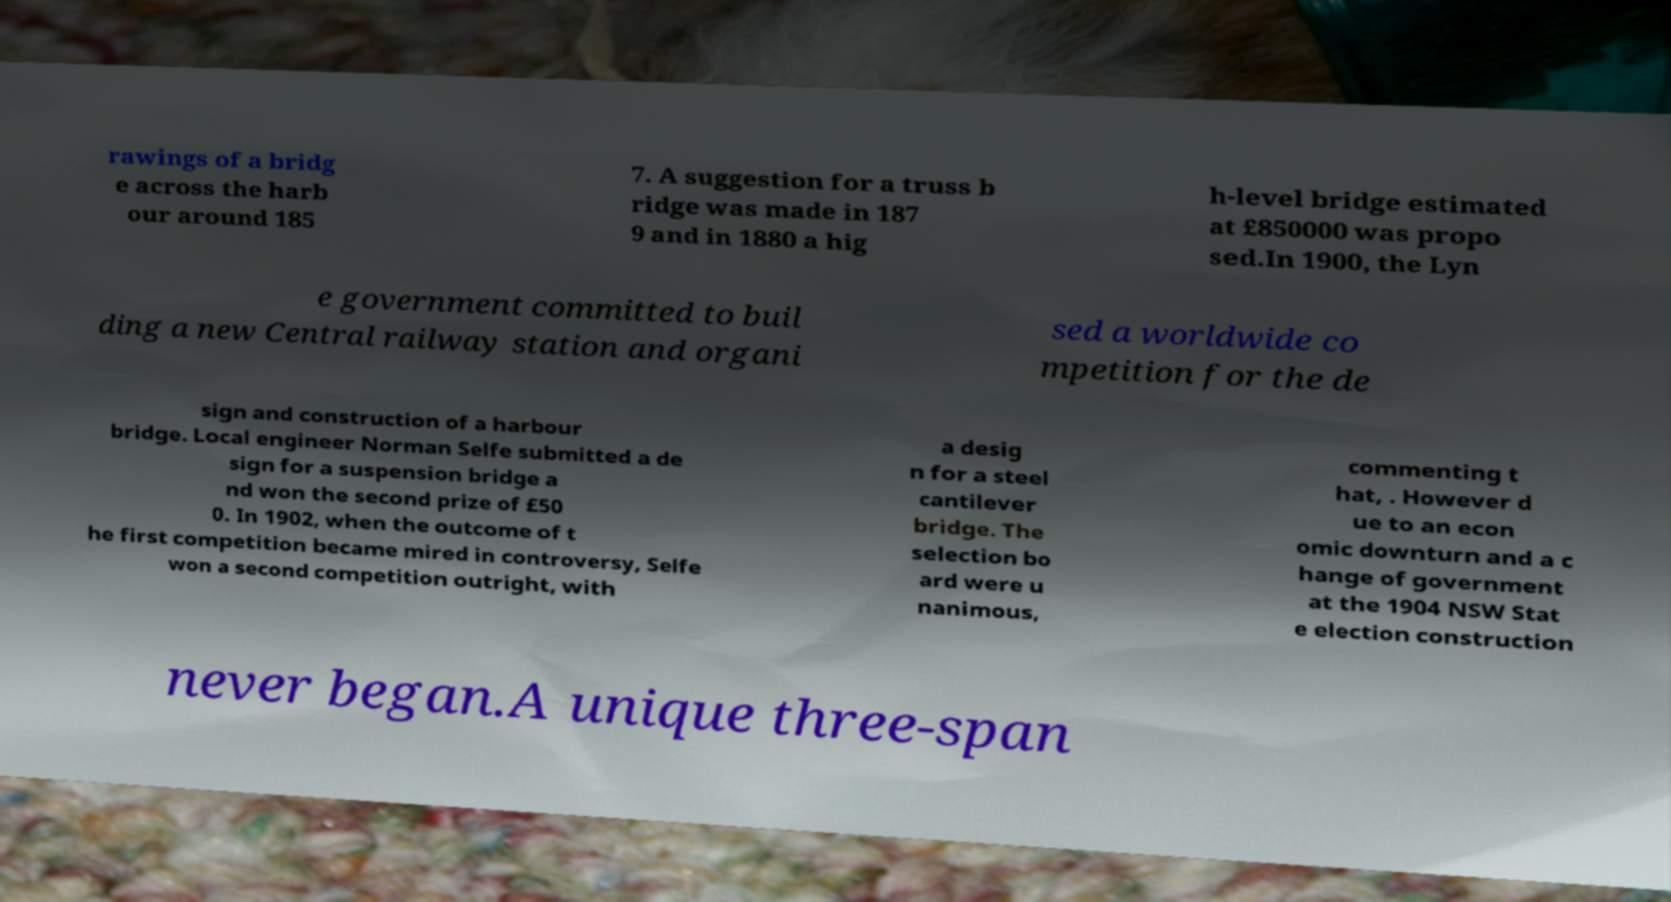There's text embedded in this image that I need extracted. Can you transcribe it verbatim? rawings of a bridg e across the harb our around 185 7. A suggestion for a truss b ridge was made in 187 9 and in 1880 a hig h-level bridge estimated at £850000 was propo sed.In 1900, the Lyn e government committed to buil ding a new Central railway station and organi sed a worldwide co mpetition for the de sign and construction of a harbour bridge. Local engineer Norman Selfe submitted a de sign for a suspension bridge a nd won the second prize of £50 0. In 1902, when the outcome of t he first competition became mired in controversy, Selfe won a second competition outright, with a desig n for a steel cantilever bridge. The selection bo ard were u nanimous, commenting t hat, . However d ue to an econ omic downturn and a c hange of government at the 1904 NSW Stat e election construction never began.A unique three-span 